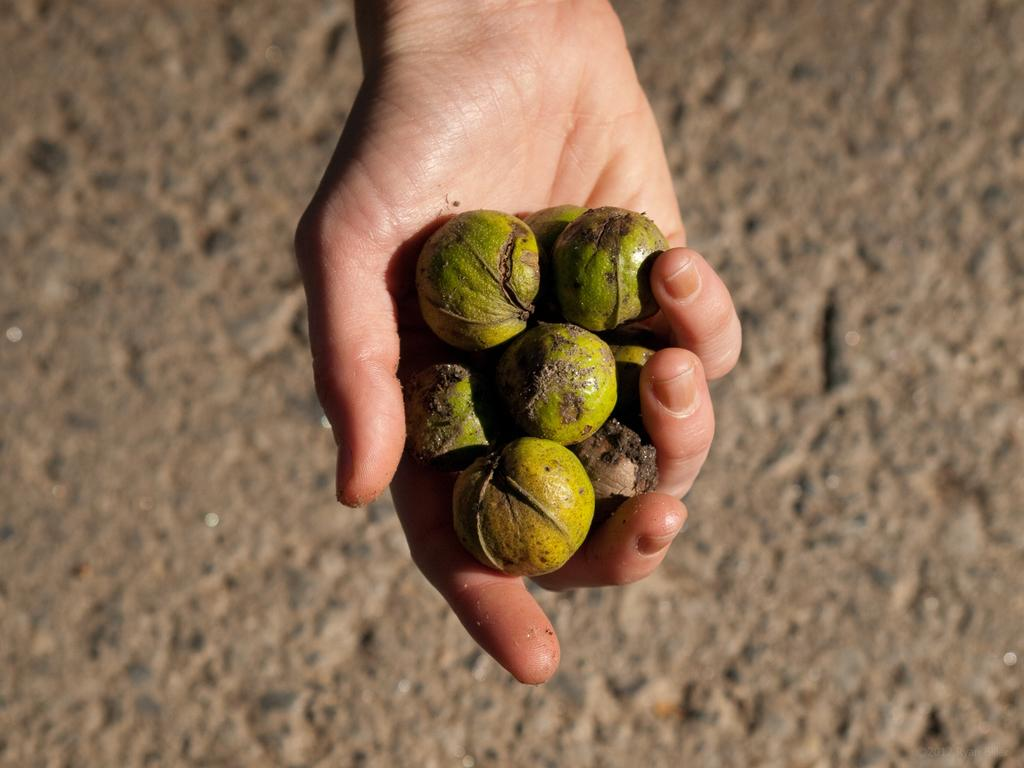What can be seen in the image? There is a hand in the image. What is the hand holding? There is an object in the hand. What type of rail is present in the image? There is no rail present in the image; it only features a hand holding an object. How many cubs can be seen playing with the twig in the image? There are no cubs or twigs present in the image. 